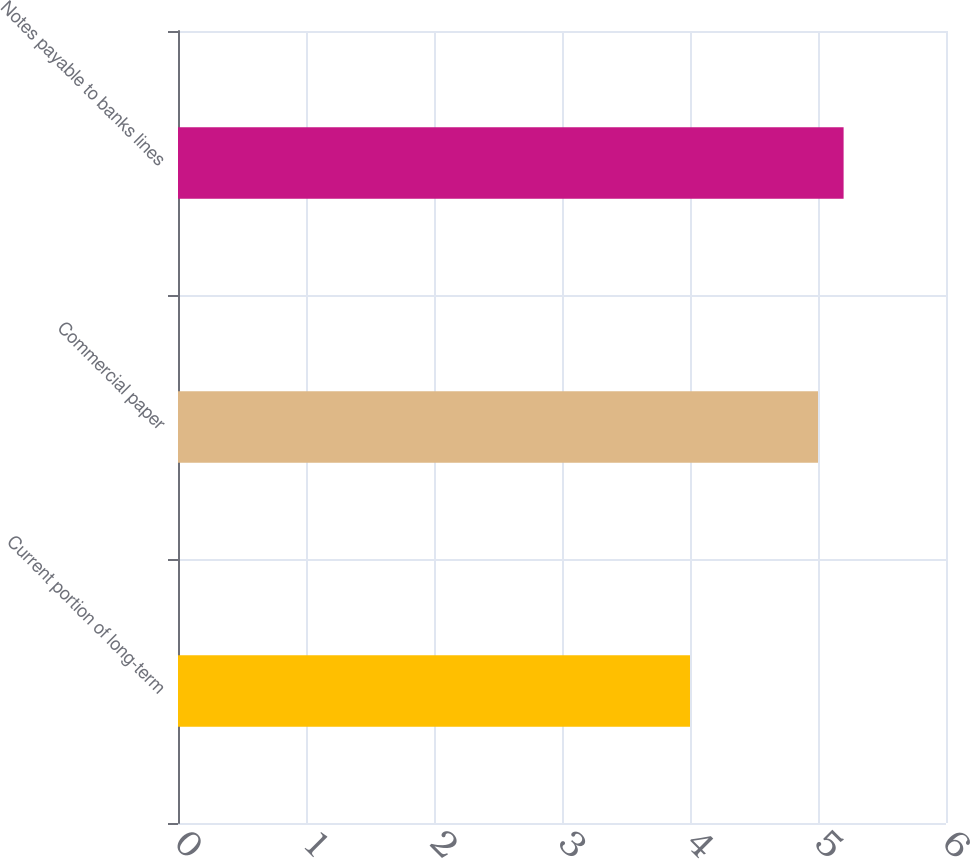<chart> <loc_0><loc_0><loc_500><loc_500><bar_chart><fcel>Current portion of long-term<fcel>Commercial paper<fcel>Notes payable to banks lines<nl><fcel>4<fcel>5<fcel>5.2<nl></chart> 